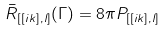Convert formula to latex. <formula><loc_0><loc_0><loc_500><loc_500>\bar { R } _ { [ [ i k ] , l ] } ( \Gamma ) = 8 \pi P _ { [ [ i k ] , l ] }</formula> 